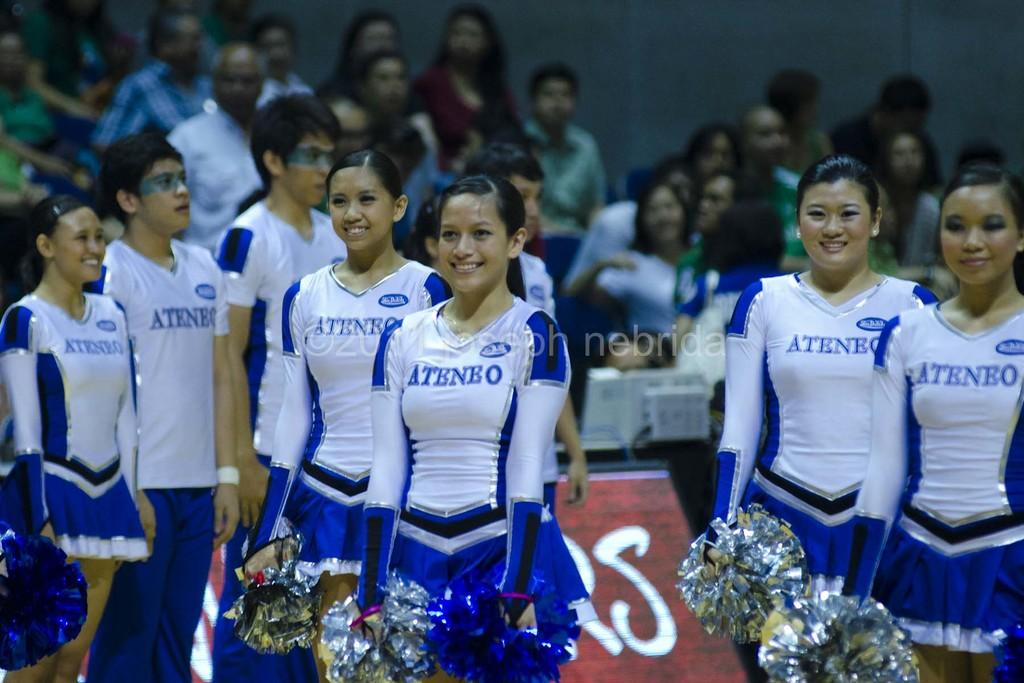<image>
Share a concise interpretation of the image provided. The Ateneo cheerleading team is dressed in blue and standing with their arms down while holidng their pom poms. 